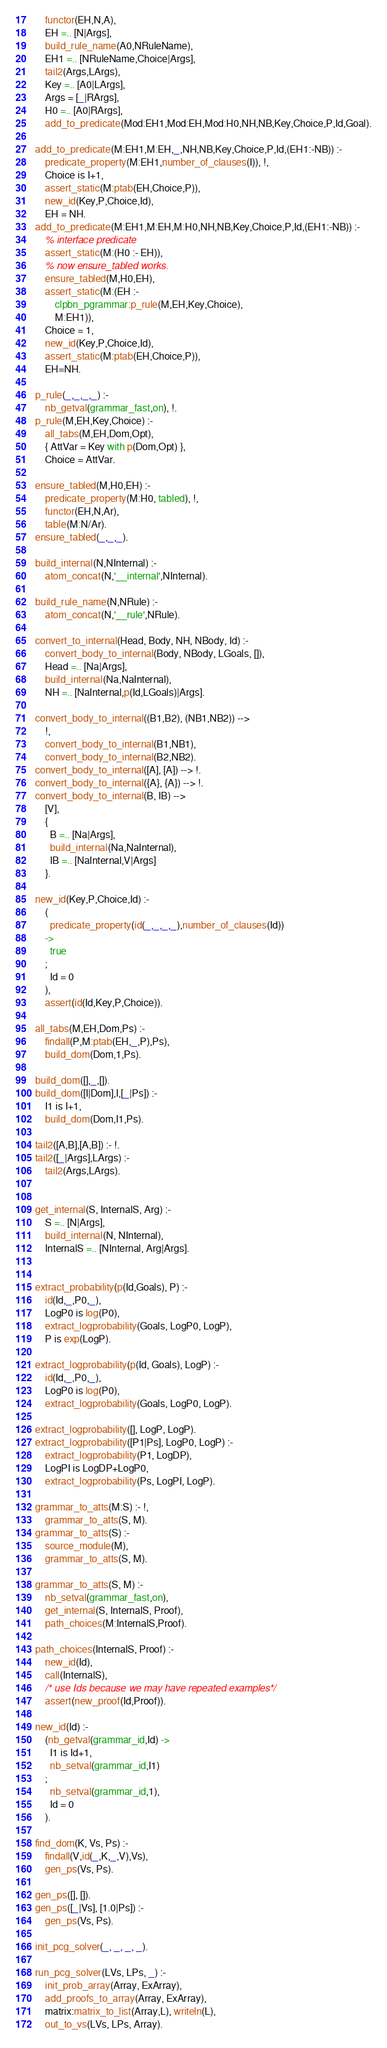<code> <loc_0><loc_0><loc_500><loc_500><_Prolog_>	functor(EH,N,A),
	EH =.. [N|Args],
	build_rule_name(A0,NRuleName),
	EH1 =.. [NRuleName,Choice|Args],
	tail2(Args,LArgs),
	Key =.. [A0|LArgs],
	Args = [_|RArgs],
	H0 =.. [A0|RArgs],
	add_to_predicate(Mod:EH1,Mod:EH,Mod:H0,NH,NB,Key,Choice,P,Id,Goal).

add_to_predicate(M:EH1,M:EH,_,NH,NB,Key,Choice,P,Id,(EH1:-NB)) :-
	predicate_property(M:EH1,number_of_clauses(I)), !,
	Choice is I+1,
	assert_static(M:ptab(EH,Choice,P)),
	new_id(Key,P,Choice,Id),
	EH = NH.
add_to_predicate(M:EH1,M:EH,M:H0,NH,NB,Key,Choice,P,Id,(EH1:-NB)) :-
	% interface predicate
	assert_static(M:(H0 :- EH)),
	% now ensure_tabled works.
	ensure_tabled(M,H0,EH),
	assert_static(M:(EH :-
		clpbn_pgrammar:p_rule(M,EH,Key,Choice),
		M:EH1)),
	Choice = 1,
	new_id(Key,P,Choice,Id),
	assert_static(M:ptab(EH,Choice,P)),
	EH=NH.

p_rule(_,_,_,_) :-
	nb_getval(grammar_fast,on), !.
p_rule(M,EH,Key,Choice) :-
	all_tabs(M,EH,Dom,Opt),
	{ AttVar = Key with p(Dom,Opt) },
	Choice = AttVar.

ensure_tabled(M,H0,EH) :-
	predicate_property(M:H0, tabled), !,
	functor(EH,N,Ar),
	table(M:N/Ar).
ensure_tabled(_,_,_).

build_internal(N,NInternal) :-
	atom_concat(N,'__internal',NInternal).

build_rule_name(N,NRule) :-
	atom_concat(N,'__rule',NRule).

convert_to_internal(Head, Body, NH, NBody, Id) :-
	convert_body_to_internal(Body, NBody, LGoals, []),
	Head =.. [Na|Args],
	build_internal(Na,NaInternal),
	NH =.. [NaInternal,p(Id,LGoals)|Args].

convert_body_to_internal((B1,B2), (NB1,NB2)) -->
	!,
	convert_body_to_internal(B1,NB1),
	convert_body_to_internal(B2,NB2).
convert_body_to_internal([A], [A]) --> !.
convert_body_to_internal({A}, {A}) --> !.
convert_body_to_internal(B, IB) -->
	[V],
	{
	  B =.. [Na|Args],
	  build_internal(Na,NaInternal),
	  IB =.. [NaInternal,V|Args]
	}.

new_id(Key,P,Choice,Id) :-
	(
	  predicate_property(id(_,_,_,_),number_of_clauses(Id))
	->
	  true
	;
	  Id = 0
	),
	assert(id(Id,Key,P,Choice)).

all_tabs(M,EH,Dom,Ps) :-
	findall(P,M:ptab(EH,_,P),Ps),
	build_dom(Dom,1,Ps).

build_dom([],_,[]).
build_dom([I|Dom],I,[_|Ps]) :-
	I1 is I+1,
	build_dom(Dom,I1,Ps).

tail2([A,B],[A,B]) :- !.
tail2([_|Args],LArgs) :-
	tail2(Args,LArgs).


get_internal(S, InternalS, Arg) :-
	S =.. [N|Args],
	build_internal(N, NInternal),
	InternalS =.. [NInternal, Arg|Args].


extract_probability(p(Id,Goals), P) :-
	id(Id,_,P0,_),
	LogP0 is log(P0),
	extract_logprobability(Goals, LogP0, LogP),
	P is exp(LogP).

extract_logprobability(p(Id, Goals), LogP) :-
	id(Id,_,P0,_),
	LogP0 is log(P0),
	extract_logprobability(Goals, LogP0, LogP).

extract_logprobability([], LogP, LogP).
extract_logprobability([P1|Ps], LogP0, LogP) :-
	extract_logprobability(P1, LogDP),
	LogPI is LogDP+LogP0,
	extract_logprobability(Ps, LogPI, LogP).

grammar_to_atts(M:S) :- !,
	grammar_to_atts(S, M).
grammar_to_atts(S) :-
	source_module(M),
	grammar_to_atts(S, M).

grammar_to_atts(S, M) :-
	nb_setval(grammar_fast,on),
	get_internal(S, InternalS, Proof),
	path_choices(M:InternalS,Proof).

path_choices(InternalS, Proof) :-
	new_id(Id),
	call(InternalS),
	/* use Ids because we may have repeated examples */
	assert(new_proof(Id,Proof)).

new_id(Id) :-
	(nb_getval(grammar_id,Id) ->
	  I1 is Id+1,
	  nb_setval(grammar_id,I1)
	;
	  nb_setval(grammar_id,1),
	  Id = 0
	).

find_dom(K, Vs, Ps) :-
	findall(V,id(_,K,_,V),Vs),
	gen_ps(Vs, Ps).

gen_ps([], []).
gen_ps([_|Vs], [1.0|Ps]) :-
	gen_ps(Vs, Ps).

init_pcg_solver(_, _, _, _).

run_pcg_solver(LVs, LPs, _) :-
	init_prob_array(Array, ExArray),
	add_proofs_to_array(Array, ExArray),
	matrix:matrix_to_list(Array,L), writeln(L),
	out_to_vs(LVs, LPs, Array).
</code> 